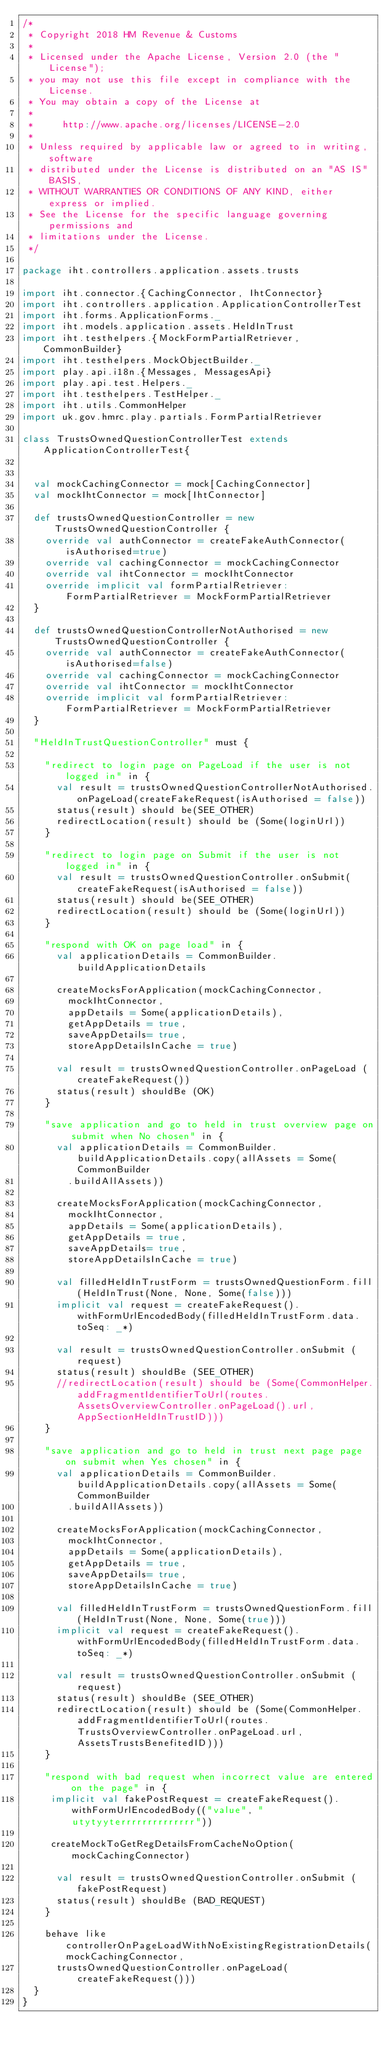<code> <loc_0><loc_0><loc_500><loc_500><_Scala_>/*
 * Copyright 2018 HM Revenue & Customs
 *
 * Licensed under the Apache License, Version 2.0 (the "License");
 * you may not use this file except in compliance with the License.
 * You may obtain a copy of the License at
 *
 *     http://www.apache.org/licenses/LICENSE-2.0
 *
 * Unless required by applicable law or agreed to in writing, software
 * distributed under the License is distributed on an "AS IS" BASIS,
 * WITHOUT WARRANTIES OR CONDITIONS OF ANY KIND, either express or implied.
 * See the License for the specific language governing permissions and
 * limitations under the License.
 */

package iht.controllers.application.assets.trusts

import iht.connector.{CachingConnector, IhtConnector}
import iht.controllers.application.ApplicationControllerTest
import iht.forms.ApplicationForms._
import iht.models.application.assets.HeldInTrust
import iht.testhelpers.{MockFormPartialRetriever, CommonBuilder}
import iht.testhelpers.MockObjectBuilder._
import play.api.i18n.{Messages, MessagesApi}
import play.api.test.Helpers._
import iht.testhelpers.TestHelper._
import iht.utils.CommonHelper
import uk.gov.hmrc.play.partials.FormPartialRetriever

class TrustsOwnedQuestionControllerTest extends ApplicationControllerTest{


  val mockCachingConnector = mock[CachingConnector]
  val mockIhtConnector = mock[IhtConnector]

  def trustsOwnedQuestionController = new TrustsOwnedQuestionController {
    override val authConnector = createFakeAuthConnector(isAuthorised=true)
    override val cachingConnector = mockCachingConnector
    override val ihtConnector = mockIhtConnector
    override implicit val formPartialRetriever: FormPartialRetriever = MockFormPartialRetriever
  }

  def trustsOwnedQuestionControllerNotAuthorised = new TrustsOwnedQuestionController {
    override val authConnector = createFakeAuthConnector(isAuthorised=false)
    override val cachingConnector = mockCachingConnector
    override val ihtConnector = mockIhtConnector
    override implicit val formPartialRetriever: FormPartialRetriever = MockFormPartialRetriever
  }

  "HeldInTrustQuestionController" must {

    "redirect to login page on PageLoad if the user is not logged in" in {
      val result = trustsOwnedQuestionControllerNotAuthorised.onPageLoad(createFakeRequest(isAuthorised = false))
      status(result) should be(SEE_OTHER)
      redirectLocation(result) should be (Some(loginUrl))
    }

    "redirect to login page on Submit if the user is not logged in" in {
      val result = trustsOwnedQuestionController.onSubmit(createFakeRequest(isAuthorised = false))
      status(result) should be(SEE_OTHER)
      redirectLocation(result) should be (Some(loginUrl))
    }

    "respond with OK on page load" in {
      val applicationDetails = CommonBuilder.buildApplicationDetails

      createMocksForApplication(mockCachingConnector,
        mockIhtConnector,
        appDetails = Some(applicationDetails),
        getAppDetails = true,
        saveAppDetails= true,
        storeAppDetailsInCache = true)

      val result = trustsOwnedQuestionController.onPageLoad (createFakeRequest())
      status(result) shouldBe (OK)
    }

    "save application and go to held in trust overview page on submit when No chosen" in {
      val applicationDetails = CommonBuilder.buildApplicationDetails.copy(allAssets = Some(CommonBuilder
        .buildAllAssets))

      createMocksForApplication(mockCachingConnector,
        mockIhtConnector,
        appDetails = Some(applicationDetails),
        getAppDetails = true,
        saveAppDetails= true,
        storeAppDetailsInCache = true)

      val filledHeldInTrustForm = trustsOwnedQuestionForm.fill(HeldInTrust(None, None, Some(false)))
      implicit val request = createFakeRequest().withFormUrlEncodedBody(filledHeldInTrustForm.data.toSeq: _*)

      val result = trustsOwnedQuestionController.onSubmit (request)
      status(result) shouldBe (SEE_OTHER)
      //redirectLocation(result) should be (Some(CommonHelper.addFragmentIdentifierToUrl(routes.AssetsOverviewController.onPageLoad().url, AppSectionHeldInTrustID)))
    }

    "save application and go to held in trust next page page on submit when Yes chosen" in {
      val applicationDetails = CommonBuilder.buildApplicationDetails.copy(allAssets = Some(CommonBuilder
        .buildAllAssets))

      createMocksForApplication(mockCachingConnector,
        mockIhtConnector,
        appDetails = Some(applicationDetails),
        getAppDetails = true,
        saveAppDetails= true,
        storeAppDetailsInCache = true)

      val filledHeldInTrustForm = trustsOwnedQuestionForm.fill(HeldInTrust(None, None, Some(true)))
      implicit val request = createFakeRequest().withFormUrlEncodedBody(filledHeldInTrustForm.data.toSeq: _*)

      val result = trustsOwnedQuestionController.onSubmit (request)
      status(result) shouldBe (SEE_OTHER)
      redirectLocation(result) should be (Some(CommonHelper.addFragmentIdentifierToUrl(routes.TrustsOverviewController.onPageLoad.url, AssetsTrustsBenefitedID)))
    }

    "respond with bad request when incorrect value are entered on the page" in {
     implicit val fakePostRequest = createFakeRequest().withFormUrlEncodedBody(("value", "utytyyterrrrrrrrrrrrrr"))

     createMockToGetRegDetailsFromCacheNoOption(mockCachingConnector)

      val result = trustsOwnedQuestionController.onSubmit (fakePostRequest)
      status(result) shouldBe (BAD_REQUEST)
    }

    behave like controllerOnPageLoadWithNoExistingRegistrationDetails(mockCachingConnector,
      trustsOwnedQuestionController.onPageLoad(createFakeRequest()))
  }
}
</code> 